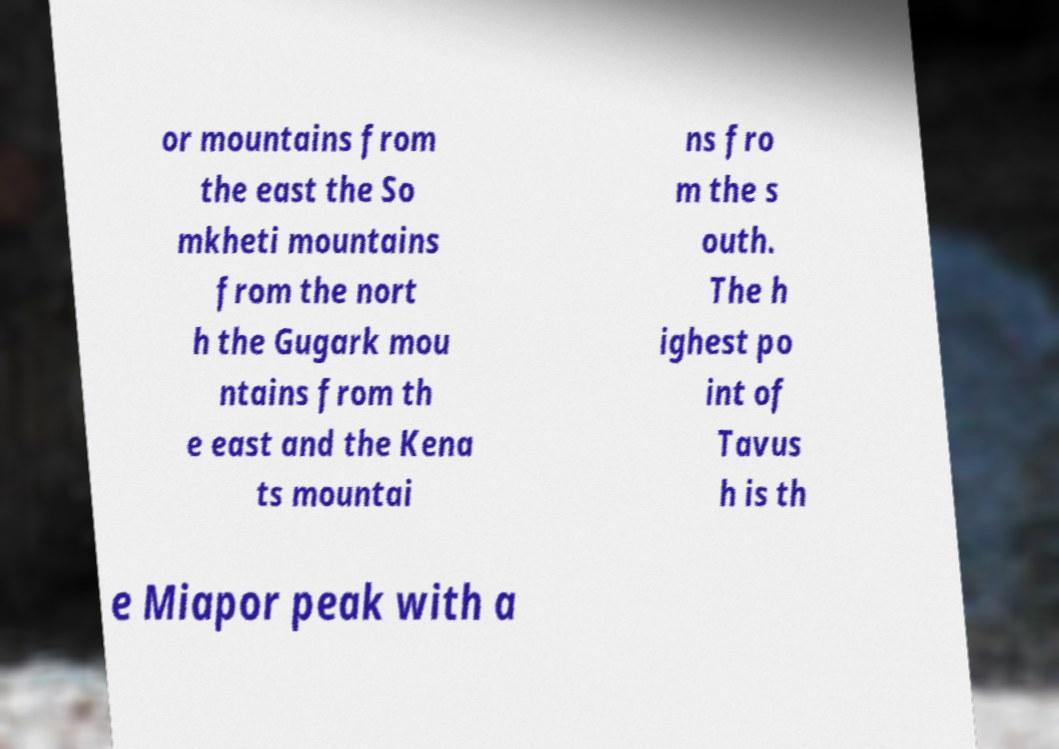Please identify and transcribe the text found in this image. or mountains from the east the So mkheti mountains from the nort h the Gugark mou ntains from th e east and the Kena ts mountai ns fro m the s outh. The h ighest po int of Tavus h is th e Miapor peak with a 